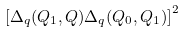<formula> <loc_0><loc_0><loc_500><loc_500>\left [ \Delta _ { q } ( Q _ { 1 } , Q ) \Delta _ { q } ( Q _ { 0 } , Q _ { 1 } ) \right ] ^ { 2 }</formula> 